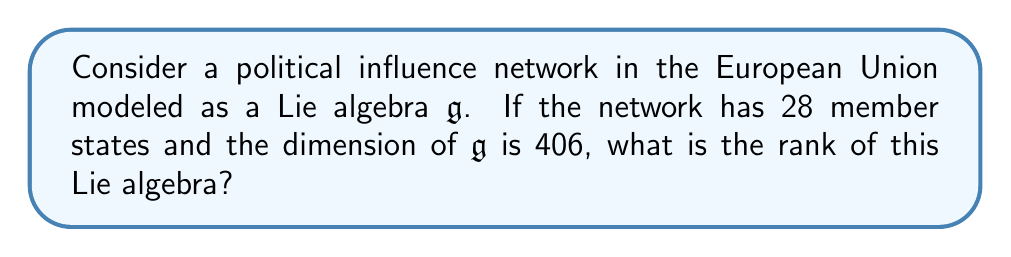Teach me how to tackle this problem. To solve this problem, we need to understand the relationship between the dimension and rank of a Lie algebra, particularly in the context of political influence networks.

1) In a political influence network, each node represents a member state, and the edges represent influence relationships.

2) The dimension of a Lie algebra $\mathfrak{g}$, denoted $\dim \mathfrak{g}$, is the number of generators or basis elements of the algebra. In this context, it represents the total number of possible influence relationships.

3) For a network with $n$ nodes, the maximum number of directed edges (including self-loops) is $n^2$.

4) The rank of a Lie algebra, denoted $\text{rank} \mathfrak{g}$, is the dimension of its Cartan subalgebra. In political networks, this can be interpreted as the number of independent power centers or factions.

5) For a simple Lie algebra of type $A_n$ (which is appropriate for modeling political networks), the relationship between dimension and rank is:

   $$\dim \mathfrak{g} = n(n+2)$$

   where $n$ is the rank of the algebra.

6) Given:
   - Number of member states = 28
   - $\dim \mathfrak{g} = 406$

7) We need to solve:
   $$406 = n(n+2)$$

8) This is a quadratic equation. Rearranging:
   $$n^2 + 2n - 406 = 0$$

9) Using the quadratic formula:
   $$n = \frac{-2 \pm \sqrt{4 + 4(406)}}{2} = \frac{-2 \pm \sqrt{1628}}{2}$$

10) Simplifying:
    $$n = -1 \pm \sqrt{407}$$

11) Since rank must be positive, we take the positive root:
    $$n = -1 + \sqrt{407} \approx 19.17$$

12) The rank must be an integer, so we round to the nearest whole number: 19.

This result suggests that in this EU political influence network, there are 19 independent power centers or factions, despite having 28 member states.
Answer: 19 